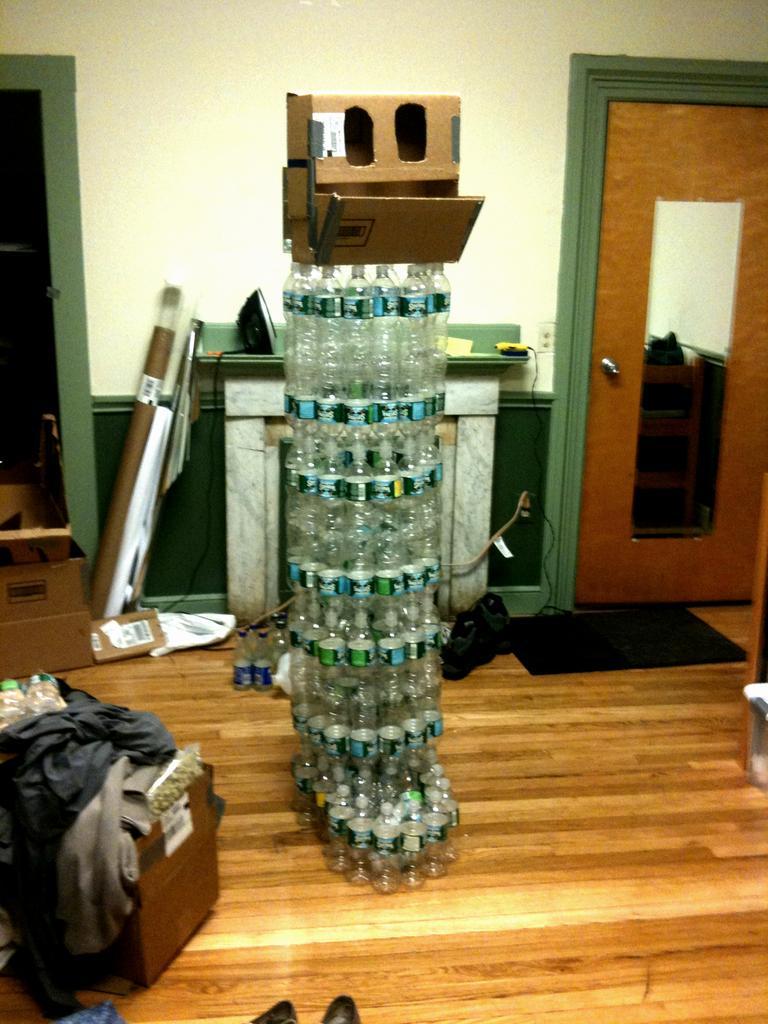How would you summarize this image in a sentence or two? In the middle its a structure which is made up of plastic bottles and on the left and right there are two doors behind them there is a wall and left down there are clothes. 